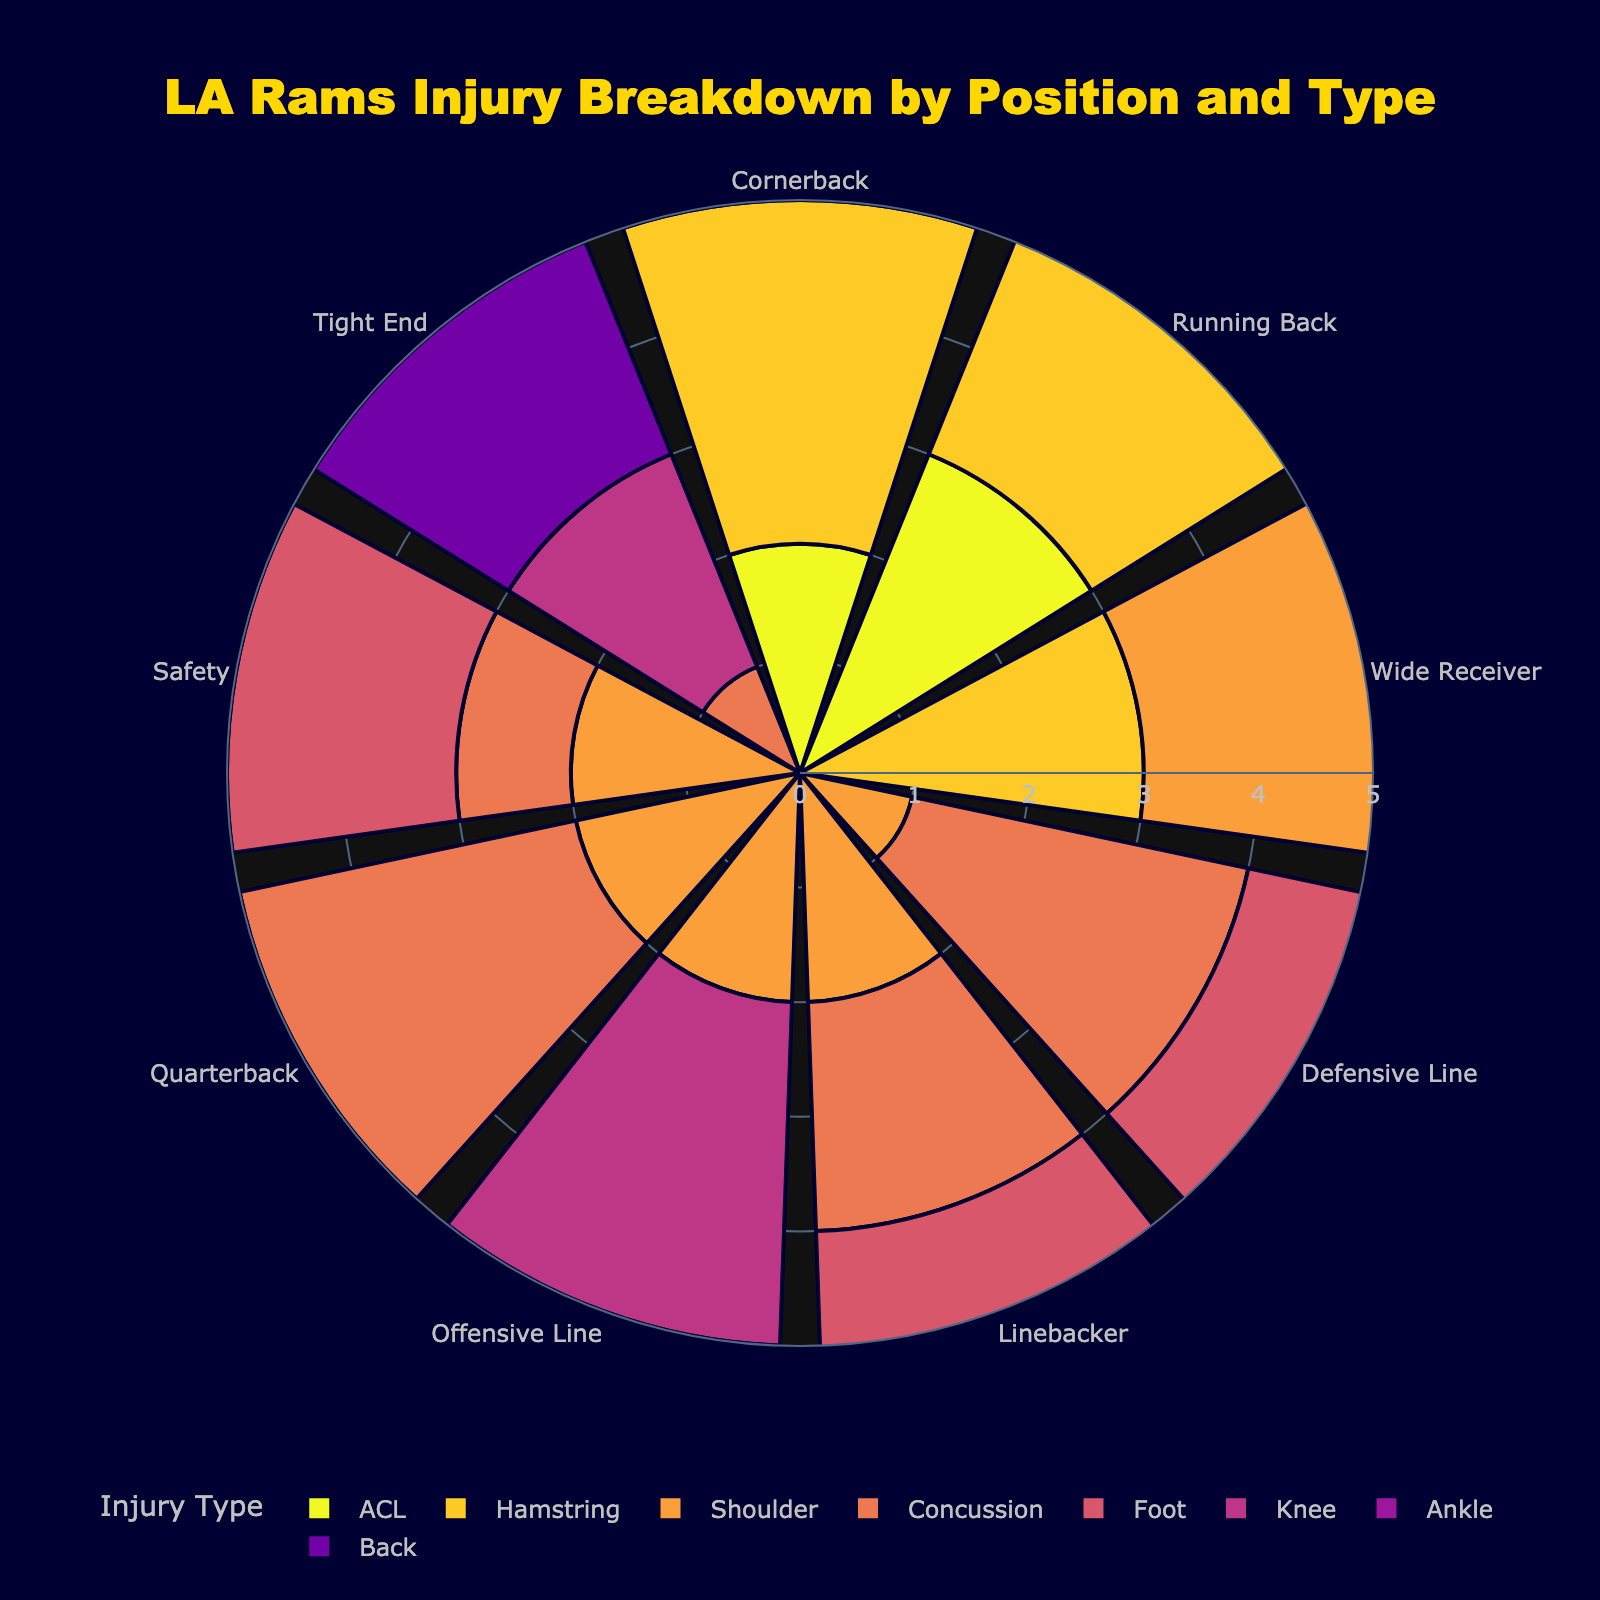What is the title of the rose chart? The title is displayed prominently at the top of the chart.
Answer: "LA Rams Injury Breakdown by Position and Type" Which injury type has the highest number of injuries for the Running Back position? Look at the Running Back section and compare the heights (number of injuries) of each injury type.
Answer: Ankle How many different injury types are represented on the chart? Count the distinct colors and their corresponding legends for different injury types.
Answer: 10 Which position has the highest total number of injuries? Sum the injuries for each position by looking at all the segments for that position.
Answer: Wide Receiver What is the total number of concussion injuries for all positions combined? Add the concussion injuries for each position by looking at the corresponding segments.
Answer: 12 Which position experienced the most shoulder injuries? Compare the shoulder injury segments across all positions and find the one with the largest segment.
Answer: Wide Receiver For the Defensive Line, which injury type had the least incidents? Look at the Defensive Line section and identify the smallest segment.
Answer: Shoulder Between Quarterback and Safety, which position had more knee injuries? Compare the knee injury segments for Quarterback and Safety.
Answer: Quarterback What is the most common injury type for the Offensive Line? Identify the largest segment in the Offensive Line section.
Answer: Ankle How do the hamstring injuries for Wide Receivers compare to those for Running Backs? Compare the heights (number of injuries) of the hamstring injury segments for both positions.
Answer: Running Backs have more hamstring injuries than Wide Receivers 